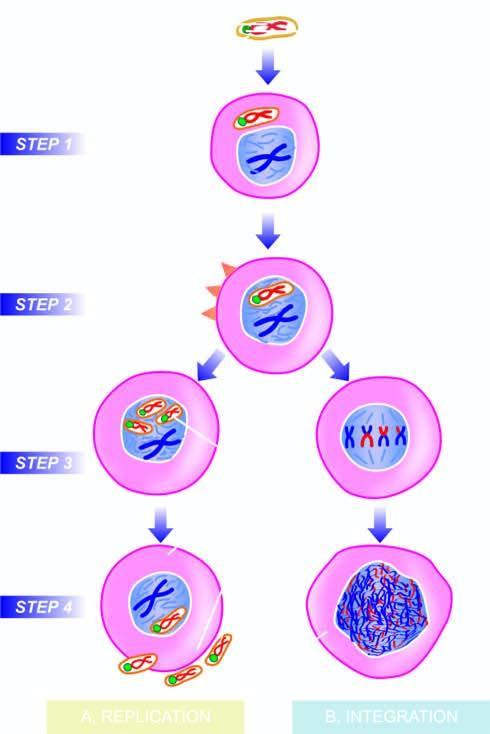what are released, accompanied by host cell lysis?
Answer the question using a single word or phrase. New virions 